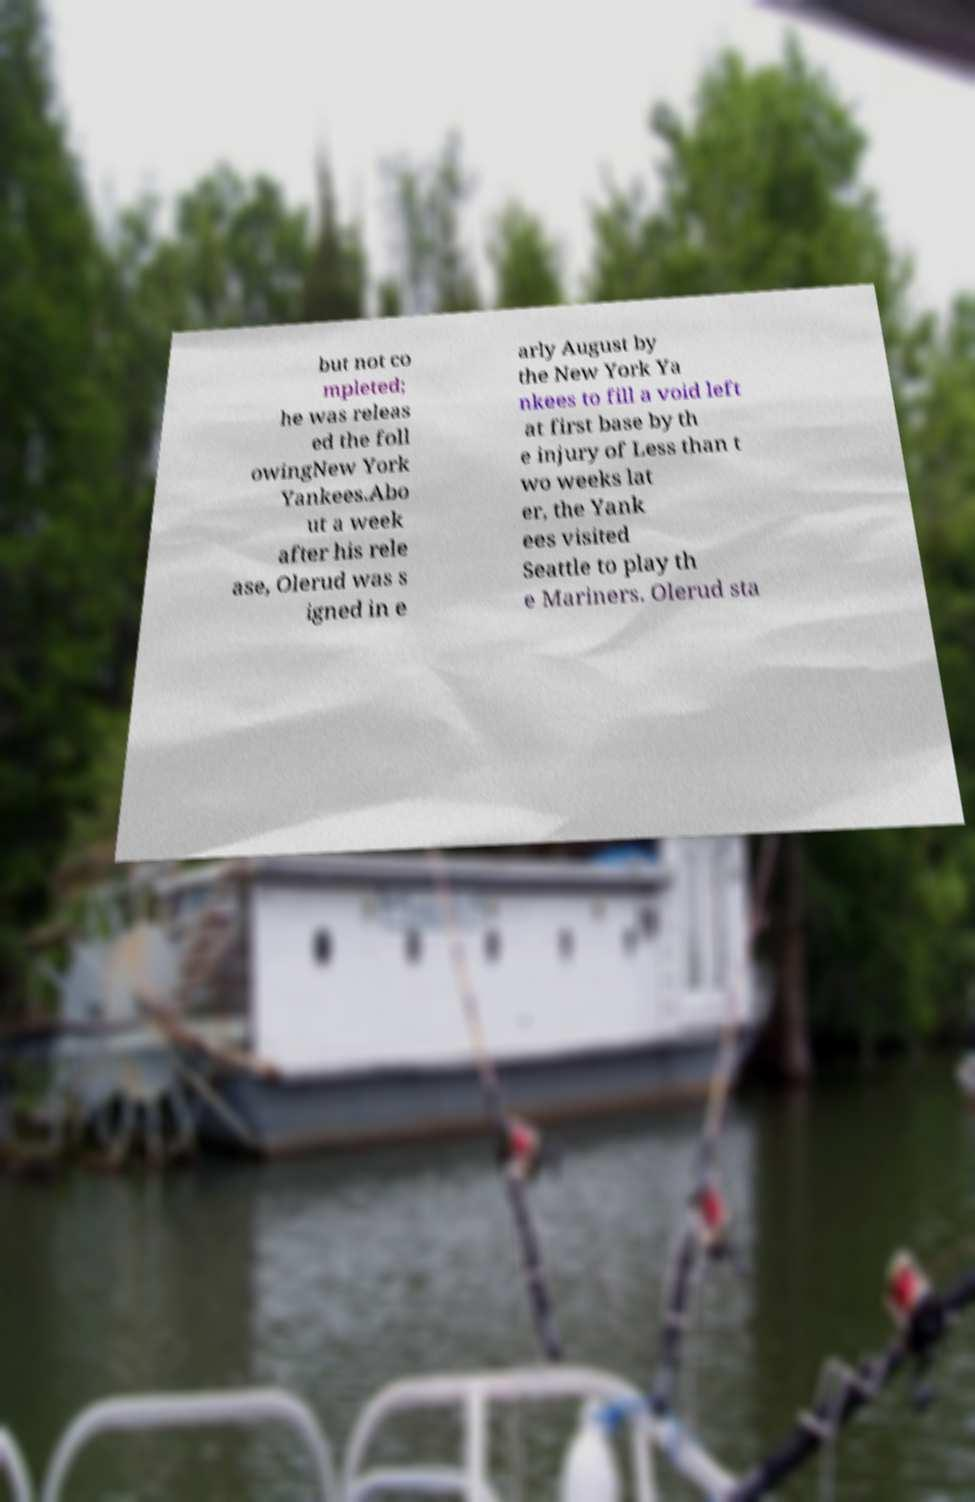For documentation purposes, I need the text within this image transcribed. Could you provide that? but not co mpleted; he was releas ed the foll owingNew York Yankees.Abo ut a week after his rele ase, Olerud was s igned in e arly August by the New York Ya nkees to fill a void left at first base by th e injury of Less than t wo weeks lat er, the Yank ees visited Seattle to play th e Mariners. Olerud sta 